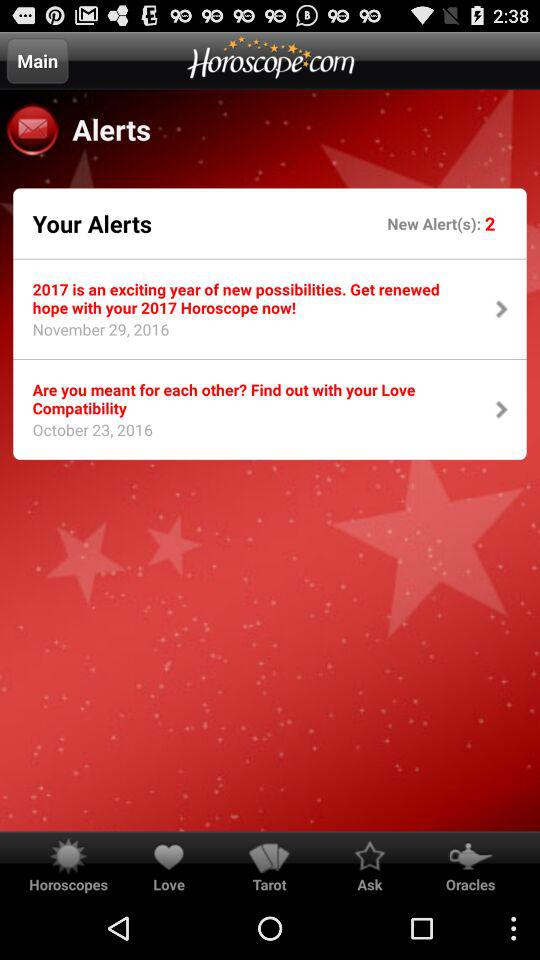What's the date of the 2 "New Alert(s)" notifications? The dates of the 2 "New Alert(s)" notifications are November 29, 2016 and October 23, 2016. 